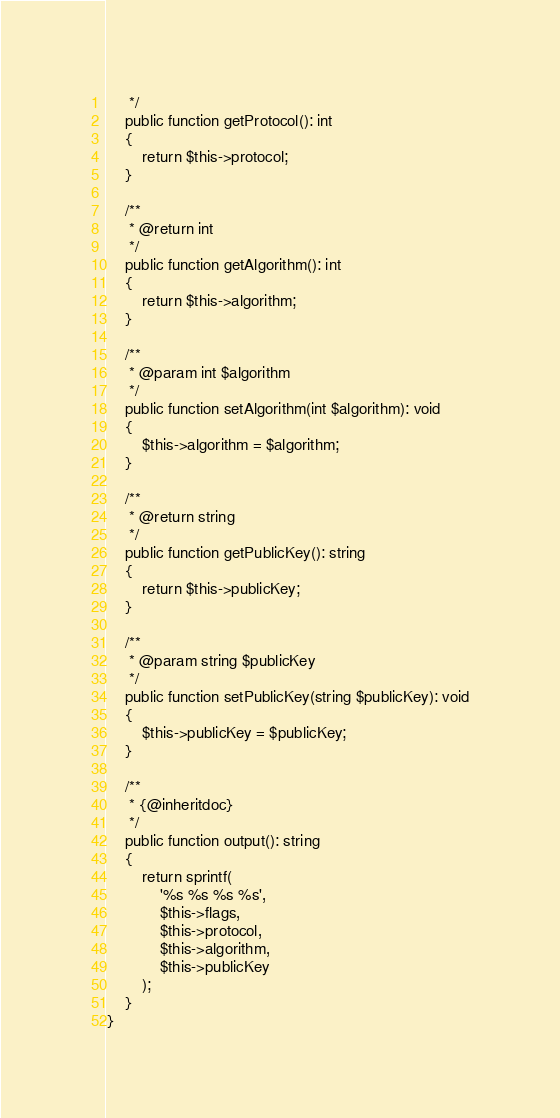<code> <loc_0><loc_0><loc_500><loc_500><_PHP_>     */
    public function getProtocol(): int
    {
        return $this->protocol;
    }

    /**
     * @return int
     */
    public function getAlgorithm(): int
    {
        return $this->algorithm;
    }

    /**
     * @param int $algorithm
     */
    public function setAlgorithm(int $algorithm): void
    {
        $this->algorithm = $algorithm;
    }

    /**
     * @return string
     */
    public function getPublicKey(): string
    {
        return $this->publicKey;
    }

    /**
     * @param string $publicKey
     */
    public function setPublicKey(string $publicKey): void
    {
        $this->publicKey = $publicKey;
    }

    /**
     * {@inheritdoc}
     */
    public function output(): string
    {
        return sprintf(
            '%s %s %s %s',
            $this->flags,
            $this->protocol,
            $this->algorithm,
            $this->publicKey
        );
    }
}
</code> 